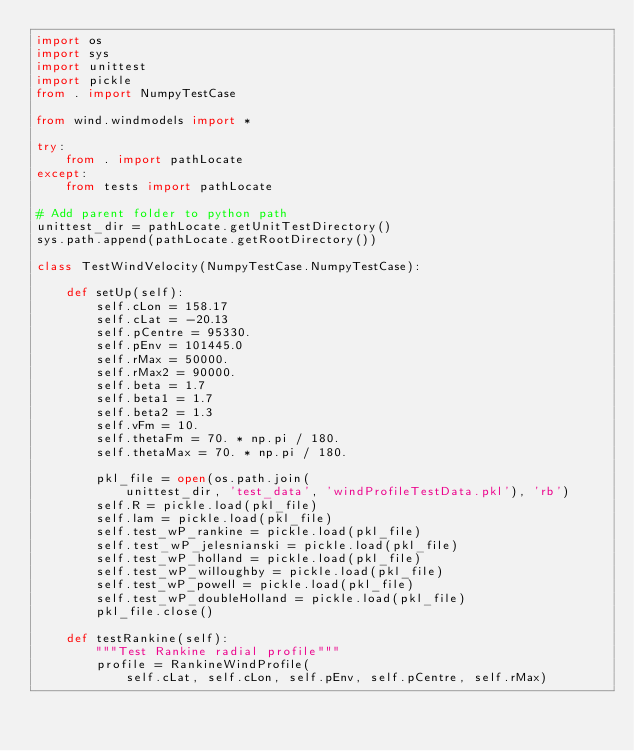Convert code to text. <code><loc_0><loc_0><loc_500><loc_500><_Python_>import os
import sys
import unittest
import pickle
from . import NumpyTestCase

from wind.windmodels import *

try:
    from . import pathLocate
except:
    from tests import pathLocate

# Add parent folder to python path
unittest_dir = pathLocate.getUnitTestDirectory()
sys.path.append(pathLocate.getRootDirectory())

class TestWindVelocity(NumpyTestCase.NumpyTestCase):

    def setUp(self):
        self.cLon = 158.17
        self.cLat = -20.13
        self.pCentre = 95330.
        self.pEnv = 101445.0
        self.rMax = 50000.
        self.rMax2 = 90000.
        self.beta = 1.7
        self.beta1 = 1.7
        self.beta2 = 1.3
        self.vFm = 10.
        self.thetaFm = 70. * np.pi / 180.
        self.thetaMax = 70. * np.pi / 180.

        pkl_file = open(os.path.join(
            unittest_dir, 'test_data', 'windProfileTestData.pkl'), 'rb')
        self.R = pickle.load(pkl_file)
        self.lam = pickle.load(pkl_file)
        self.test_wP_rankine = pickle.load(pkl_file)
        self.test_wP_jelesnianski = pickle.load(pkl_file)
        self.test_wP_holland = pickle.load(pkl_file)
        self.test_wP_willoughby = pickle.load(pkl_file)
        self.test_wP_powell = pickle.load(pkl_file)
        self.test_wP_doubleHolland = pickle.load(pkl_file)
        pkl_file.close()

    def testRankine(self):
        """Test Rankine radial profile"""
        profile = RankineWindProfile(
            self.cLat, self.cLon, self.pEnv, self.pCentre, self.rMax)</code> 